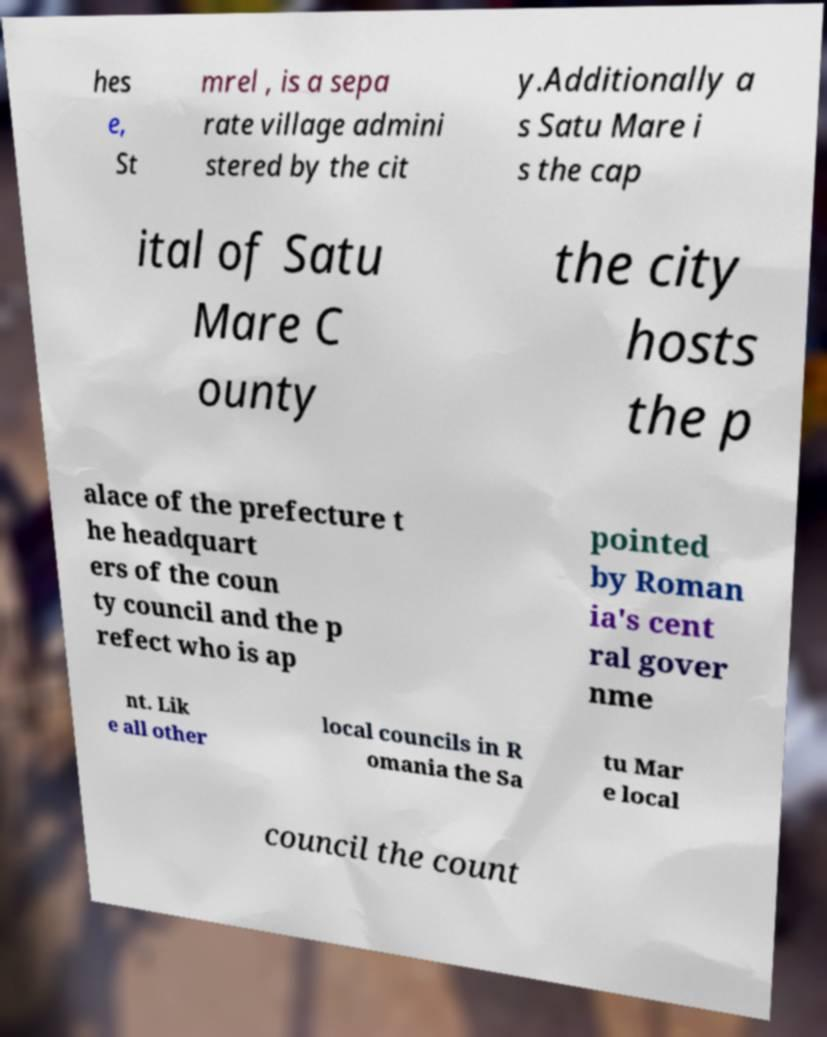Can you accurately transcribe the text from the provided image for me? hes e, St mrel , is a sepa rate village admini stered by the cit y.Additionally a s Satu Mare i s the cap ital of Satu Mare C ounty the city hosts the p alace of the prefecture t he headquart ers of the coun ty council and the p refect who is ap pointed by Roman ia's cent ral gover nme nt. Lik e all other local councils in R omania the Sa tu Mar e local council the count 